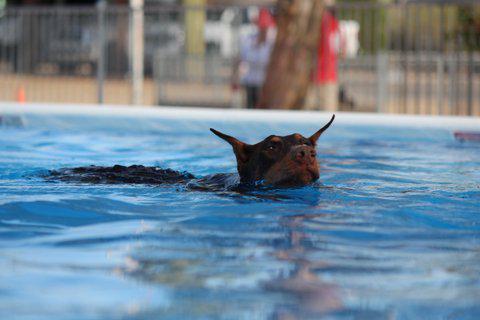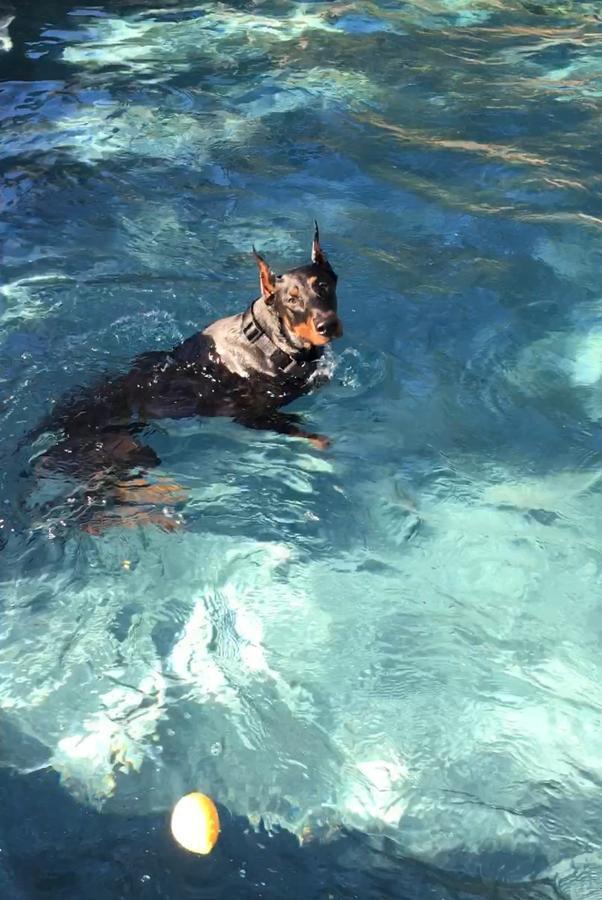The first image is the image on the left, the second image is the image on the right. Analyze the images presented: Is the assertion "The dog in each image is alone in the water." valid? Answer yes or no. Yes. The first image is the image on the left, the second image is the image on the right. Evaluate the accuracy of this statement regarding the images: "There are three animals in the water.". Is it true? Answer yes or no. No. 